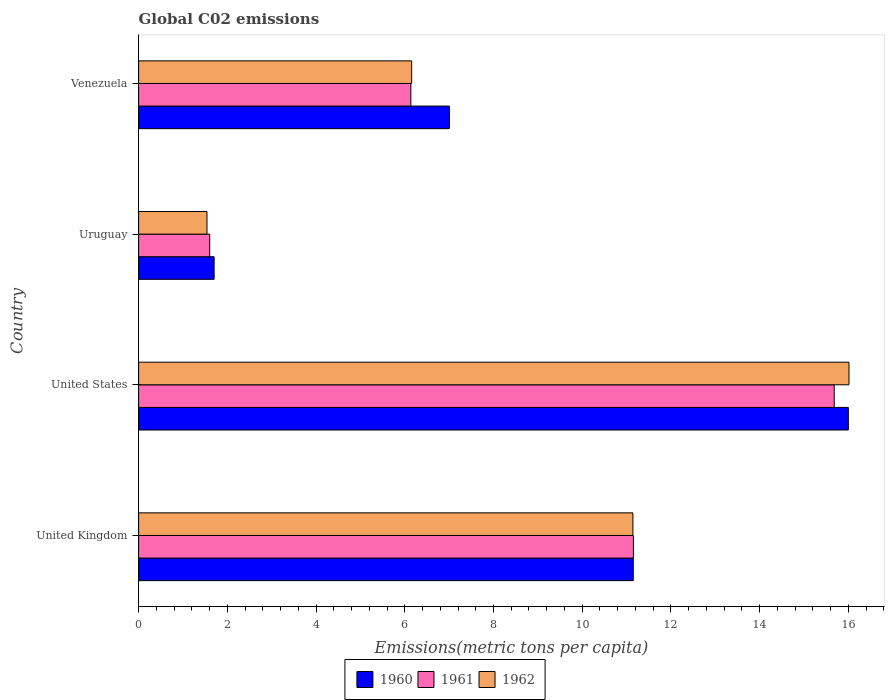How many different coloured bars are there?
Keep it short and to the point. 3. How many groups of bars are there?
Ensure brevity in your answer.  4. Are the number of bars per tick equal to the number of legend labels?
Offer a very short reply. Yes. How many bars are there on the 4th tick from the top?
Your answer should be compact. 3. How many bars are there on the 1st tick from the bottom?
Your answer should be compact. 3. What is the label of the 1st group of bars from the top?
Provide a short and direct response. Venezuela. What is the amount of CO2 emitted in in 1961 in United States?
Your answer should be very brief. 15.68. Across all countries, what is the maximum amount of CO2 emitted in in 1960?
Your answer should be compact. 16. Across all countries, what is the minimum amount of CO2 emitted in in 1962?
Your answer should be very brief. 1.54. In which country was the amount of CO2 emitted in in 1961 maximum?
Offer a very short reply. United States. In which country was the amount of CO2 emitted in in 1960 minimum?
Keep it short and to the point. Uruguay. What is the total amount of CO2 emitted in in 1962 in the graph?
Make the answer very short. 34.85. What is the difference between the amount of CO2 emitted in in 1961 in United Kingdom and that in Venezuela?
Ensure brevity in your answer.  5.02. What is the difference between the amount of CO2 emitted in in 1961 in Venezuela and the amount of CO2 emitted in in 1960 in Uruguay?
Offer a terse response. 4.44. What is the average amount of CO2 emitted in in 1962 per country?
Your answer should be compact. 8.71. What is the difference between the amount of CO2 emitted in in 1962 and amount of CO2 emitted in in 1960 in Uruguay?
Ensure brevity in your answer.  -0.16. In how many countries, is the amount of CO2 emitted in in 1962 greater than 12.8 metric tons per capita?
Your response must be concise. 1. What is the ratio of the amount of CO2 emitted in in 1961 in United Kingdom to that in Uruguay?
Ensure brevity in your answer.  6.96. What is the difference between the highest and the second highest amount of CO2 emitted in in 1962?
Offer a terse response. 4.87. What is the difference between the highest and the lowest amount of CO2 emitted in in 1962?
Your answer should be compact. 14.47. In how many countries, is the amount of CO2 emitted in in 1961 greater than the average amount of CO2 emitted in in 1961 taken over all countries?
Your answer should be compact. 2. Is the sum of the amount of CO2 emitted in in 1962 in United States and Venezuela greater than the maximum amount of CO2 emitted in in 1961 across all countries?
Keep it short and to the point. Yes. What does the 3rd bar from the top in United Kingdom represents?
Keep it short and to the point. 1960. What does the 3rd bar from the bottom in Uruguay represents?
Make the answer very short. 1962. Is it the case that in every country, the sum of the amount of CO2 emitted in in 1961 and amount of CO2 emitted in in 1960 is greater than the amount of CO2 emitted in in 1962?
Make the answer very short. Yes. How many bars are there?
Offer a terse response. 12. Are all the bars in the graph horizontal?
Your answer should be very brief. Yes. How many countries are there in the graph?
Make the answer very short. 4. Does the graph contain any zero values?
Give a very brief answer. No. Does the graph contain grids?
Offer a terse response. No. Where does the legend appear in the graph?
Provide a succinct answer. Bottom center. How are the legend labels stacked?
Keep it short and to the point. Horizontal. What is the title of the graph?
Your answer should be very brief. Global C02 emissions. Does "1996" appear as one of the legend labels in the graph?
Give a very brief answer. No. What is the label or title of the X-axis?
Keep it short and to the point. Emissions(metric tons per capita). What is the Emissions(metric tons per capita) of 1960 in United Kingdom?
Ensure brevity in your answer.  11.15. What is the Emissions(metric tons per capita) in 1961 in United Kingdom?
Your response must be concise. 11.15. What is the Emissions(metric tons per capita) of 1962 in United Kingdom?
Offer a terse response. 11.14. What is the Emissions(metric tons per capita) of 1960 in United States?
Keep it short and to the point. 16. What is the Emissions(metric tons per capita) in 1961 in United States?
Your answer should be compact. 15.68. What is the Emissions(metric tons per capita) of 1962 in United States?
Give a very brief answer. 16.01. What is the Emissions(metric tons per capita) in 1960 in Uruguay?
Offer a very short reply. 1.7. What is the Emissions(metric tons per capita) of 1961 in Uruguay?
Your answer should be very brief. 1.6. What is the Emissions(metric tons per capita) of 1962 in Uruguay?
Offer a very short reply. 1.54. What is the Emissions(metric tons per capita) in 1960 in Venezuela?
Provide a short and direct response. 7.01. What is the Emissions(metric tons per capita) in 1961 in Venezuela?
Provide a short and direct response. 6.14. What is the Emissions(metric tons per capita) in 1962 in Venezuela?
Offer a terse response. 6.16. Across all countries, what is the maximum Emissions(metric tons per capita) of 1960?
Provide a short and direct response. 16. Across all countries, what is the maximum Emissions(metric tons per capita) in 1961?
Provide a succinct answer. 15.68. Across all countries, what is the maximum Emissions(metric tons per capita) in 1962?
Your answer should be compact. 16.01. Across all countries, what is the minimum Emissions(metric tons per capita) of 1960?
Provide a short and direct response. 1.7. Across all countries, what is the minimum Emissions(metric tons per capita) in 1961?
Keep it short and to the point. 1.6. Across all countries, what is the minimum Emissions(metric tons per capita) of 1962?
Ensure brevity in your answer.  1.54. What is the total Emissions(metric tons per capita) of 1960 in the graph?
Your answer should be compact. 35.86. What is the total Emissions(metric tons per capita) in 1961 in the graph?
Provide a succinct answer. 34.58. What is the total Emissions(metric tons per capita) of 1962 in the graph?
Your answer should be compact. 34.85. What is the difference between the Emissions(metric tons per capita) in 1960 in United Kingdom and that in United States?
Ensure brevity in your answer.  -4.85. What is the difference between the Emissions(metric tons per capita) in 1961 in United Kingdom and that in United States?
Your response must be concise. -4.53. What is the difference between the Emissions(metric tons per capita) of 1962 in United Kingdom and that in United States?
Keep it short and to the point. -4.87. What is the difference between the Emissions(metric tons per capita) of 1960 in United Kingdom and that in Uruguay?
Your answer should be very brief. 9.45. What is the difference between the Emissions(metric tons per capita) in 1961 in United Kingdom and that in Uruguay?
Your response must be concise. 9.55. What is the difference between the Emissions(metric tons per capita) in 1962 in United Kingdom and that in Uruguay?
Your response must be concise. 9.6. What is the difference between the Emissions(metric tons per capita) in 1960 in United Kingdom and that in Venezuela?
Give a very brief answer. 4.15. What is the difference between the Emissions(metric tons per capita) of 1961 in United Kingdom and that in Venezuela?
Offer a terse response. 5.02. What is the difference between the Emissions(metric tons per capita) in 1962 in United Kingdom and that in Venezuela?
Give a very brief answer. 4.99. What is the difference between the Emissions(metric tons per capita) in 1960 in United States and that in Uruguay?
Make the answer very short. 14.3. What is the difference between the Emissions(metric tons per capita) in 1961 in United States and that in Uruguay?
Ensure brevity in your answer.  14.08. What is the difference between the Emissions(metric tons per capita) of 1962 in United States and that in Uruguay?
Keep it short and to the point. 14.47. What is the difference between the Emissions(metric tons per capita) in 1960 in United States and that in Venezuela?
Make the answer very short. 8.99. What is the difference between the Emissions(metric tons per capita) of 1961 in United States and that in Venezuela?
Offer a terse response. 9.54. What is the difference between the Emissions(metric tons per capita) of 1962 in United States and that in Venezuela?
Make the answer very short. 9.86. What is the difference between the Emissions(metric tons per capita) of 1960 in Uruguay and that in Venezuela?
Make the answer very short. -5.3. What is the difference between the Emissions(metric tons per capita) of 1961 in Uruguay and that in Venezuela?
Give a very brief answer. -4.53. What is the difference between the Emissions(metric tons per capita) in 1962 in Uruguay and that in Venezuela?
Offer a terse response. -4.61. What is the difference between the Emissions(metric tons per capita) of 1960 in United Kingdom and the Emissions(metric tons per capita) of 1961 in United States?
Provide a short and direct response. -4.53. What is the difference between the Emissions(metric tons per capita) in 1960 in United Kingdom and the Emissions(metric tons per capita) in 1962 in United States?
Provide a short and direct response. -4.86. What is the difference between the Emissions(metric tons per capita) in 1961 in United Kingdom and the Emissions(metric tons per capita) in 1962 in United States?
Your answer should be compact. -4.86. What is the difference between the Emissions(metric tons per capita) of 1960 in United Kingdom and the Emissions(metric tons per capita) of 1961 in Uruguay?
Offer a terse response. 9.55. What is the difference between the Emissions(metric tons per capita) of 1960 in United Kingdom and the Emissions(metric tons per capita) of 1962 in Uruguay?
Provide a succinct answer. 9.61. What is the difference between the Emissions(metric tons per capita) of 1961 in United Kingdom and the Emissions(metric tons per capita) of 1962 in Uruguay?
Make the answer very short. 9.61. What is the difference between the Emissions(metric tons per capita) in 1960 in United Kingdom and the Emissions(metric tons per capita) in 1961 in Venezuela?
Your answer should be compact. 5.01. What is the difference between the Emissions(metric tons per capita) in 1960 in United Kingdom and the Emissions(metric tons per capita) in 1962 in Venezuela?
Provide a short and direct response. 5. What is the difference between the Emissions(metric tons per capita) of 1961 in United Kingdom and the Emissions(metric tons per capita) of 1962 in Venezuela?
Offer a terse response. 5. What is the difference between the Emissions(metric tons per capita) in 1960 in United States and the Emissions(metric tons per capita) in 1961 in Uruguay?
Offer a terse response. 14.4. What is the difference between the Emissions(metric tons per capita) of 1960 in United States and the Emissions(metric tons per capita) of 1962 in Uruguay?
Offer a very short reply. 14.46. What is the difference between the Emissions(metric tons per capita) in 1961 in United States and the Emissions(metric tons per capita) in 1962 in Uruguay?
Ensure brevity in your answer.  14.14. What is the difference between the Emissions(metric tons per capita) in 1960 in United States and the Emissions(metric tons per capita) in 1961 in Venezuela?
Give a very brief answer. 9.86. What is the difference between the Emissions(metric tons per capita) of 1960 in United States and the Emissions(metric tons per capita) of 1962 in Venezuela?
Your response must be concise. 9.84. What is the difference between the Emissions(metric tons per capita) of 1961 in United States and the Emissions(metric tons per capita) of 1962 in Venezuela?
Your answer should be very brief. 9.53. What is the difference between the Emissions(metric tons per capita) in 1960 in Uruguay and the Emissions(metric tons per capita) in 1961 in Venezuela?
Provide a short and direct response. -4.44. What is the difference between the Emissions(metric tons per capita) of 1960 in Uruguay and the Emissions(metric tons per capita) of 1962 in Venezuela?
Provide a short and direct response. -4.45. What is the difference between the Emissions(metric tons per capita) in 1961 in Uruguay and the Emissions(metric tons per capita) in 1962 in Venezuela?
Offer a terse response. -4.55. What is the average Emissions(metric tons per capita) of 1960 per country?
Provide a short and direct response. 8.96. What is the average Emissions(metric tons per capita) of 1961 per country?
Give a very brief answer. 8.64. What is the average Emissions(metric tons per capita) of 1962 per country?
Your response must be concise. 8.71. What is the difference between the Emissions(metric tons per capita) in 1960 and Emissions(metric tons per capita) in 1961 in United Kingdom?
Your answer should be compact. -0. What is the difference between the Emissions(metric tons per capita) in 1960 and Emissions(metric tons per capita) in 1962 in United Kingdom?
Give a very brief answer. 0.01. What is the difference between the Emissions(metric tons per capita) in 1961 and Emissions(metric tons per capita) in 1962 in United Kingdom?
Offer a very short reply. 0.01. What is the difference between the Emissions(metric tons per capita) in 1960 and Emissions(metric tons per capita) in 1961 in United States?
Keep it short and to the point. 0.32. What is the difference between the Emissions(metric tons per capita) in 1960 and Emissions(metric tons per capita) in 1962 in United States?
Give a very brief answer. -0.01. What is the difference between the Emissions(metric tons per capita) of 1961 and Emissions(metric tons per capita) of 1962 in United States?
Provide a succinct answer. -0.33. What is the difference between the Emissions(metric tons per capita) of 1960 and Emissions(metric tons per capita) of 1961 in Uruguay?
Your answer should be very brief. 0.1. What is the difference between the Emissions(metric tons per capita) of 1960 and Emissions(metric tons per capita) of 1962 in Uruguay?
Your answer should be compact. 0.16. What is the difference between the Emissions(metric tons per capita) of 1961 and Emissions(metric tons per capita) of 1962 in Uruguay?
Offer a very short reply. 0.06. What is the difference between the Emissions(metric tons per capita) in 1960 and Emissions(metric tons per capita) in 1961 in Venezuela?
Provide a short and direct response. 0.87. What is the difference between the Emissions(metric tons per capita) in 1960 and Emissions(metric tons per capita) in 1962 in Venezuela?
Provide a succinct answer. 0.85. What is the difference between the Emissions(metric tons per capita) in 1961 and Emissions(metric tons per capita) in 1962 in Venezuela?
Make the answer very short. -0.02. What is the ratio of the Emissions(metric tons per capita) in 1960 in United Kingdom to that in United States?
Your answer should be very brief. 0.7. What is the ratio of the Emissions(metric tons per capita) in 1961 in United Kingdom to that in United States?
Your answer should be compact. 0.71. What is the ratio of the Emissions(metric tons per capita) in 1962 in United Kingdom to that in United States?
Your response must be concise. 0.7. What is the ratio of the Emissions(metric tons per capita) of 1960 in United Kingdom to that in Uruguay?
Provide a short and direct response. 6.55. What is the ratio of the Emissions(metric tons per capita) of 1961 in United Kingdom to that in Uruguay?
Keep it short and to the point. 6.96. What is the ratio of the Emissions(metric tons per capita) of 1962 in United Kingdom to that in Uruguay?
Provide a succinct answer. 7.23. What is the ratio of the Emissions(metric tons per capita) of 1960 in United Kingdom to that in Venezuela?
Your response must be concise. 1.59. What is the ratio of the Emissions(metric tons per capita) in 1961 in United Kingdom to that in Venezuela?
Offer a terse response. 1.82. What is the ratio of the Emissions(metric tons per capita) in 1962 in United Kingdom to that in Venezuela?
Your response must be concise. 1.81. What is the ratio of the Emissions(metric tons per capita) in 1960 in United States to that in Uruguay?
Your answer should be compact. 9.4. What is the ratio of the Emissions(metric tons per capita) in 1961 in United States to that in Uruguay?
Your answer should be compact. 9.78. What is the ratio of the Emissions(metric tons per capita) of 1962 in United States to that in Uruguay?
Make the answer very short. 10.39. What is the ratio of the Emissions(metric tons per capita) in 1960 in United States to that in Venezuela?
Provide a succinct answer. 2.28. What is the ratio of the Emissions(metric tons per capita) in 1961 in United States to that in Venezuela?
Provide a succinct answer. 2.56. What is the ratio of the Emissions(metric tons per capita) of 1962 in United States to that in Venezuela?
Your answer should be very brief. 2.6. What is the ratio of the Emissions(metric tons per capita) of 1960 in Uruguay to that in Venezuela?
Ensure brevity in your answer.  0.24. What is the ratio of the Emissions(metric tons per capita) of 1961 in Uruguay to that in Venezuela?
Ensure brevity in your answer.  0.26. What is the ratio of the Emissions(metric tons per capita) in 1962 in Uruguay to that in Venezuela?
Keep it short and to the point. 0.25. What is the difference between the highest and the second highest Emissions(metric tons per capita) in 1960?
Your answer should be compact. 4.85. What is the difference between the highest and the second highest Emissions(metric tons per capita) of 1961?
Your response must be concise. 4.53. What is the difference between the highest and the second highest Emissions(metric tons per capita) in 1962?
Give a very brief answer. 4.87. What is the difference between the highest and the lowest Emissions(metric tons per capita) in 1960?
Your response must be concise. 14.3. What is the difference between the highest and the lowest Emissions(metric tons per capita) of 1961?
Provide a short and direct response. 14.08. What is the difference between the highest and the lowest Emissions(metric tons per capita) in 1962?
Ensure brevity in your answer.  14.47. 